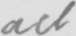Can you read and transcribe this handwriting? act 